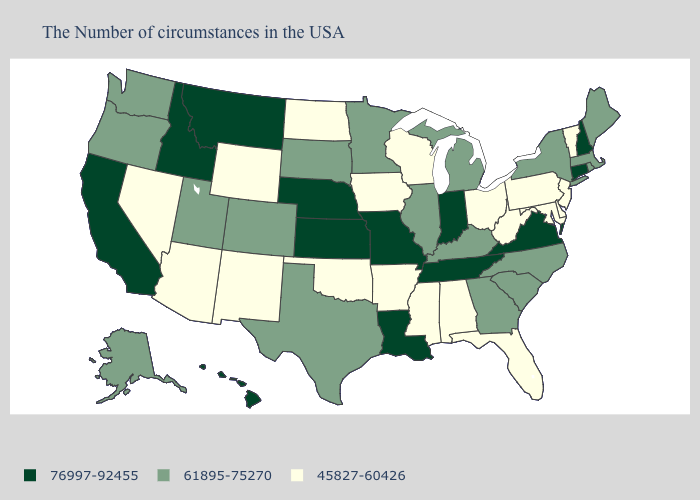What is the lowest value in the USA?
Keep it brief. 45827-60426. Name the states that have a value in the range 76997-92455?
Concise answer only. New Hampshire, Connecticut, Virginia, Indiana, Tennessee, Louisiana, Missouri, Kansas, Nebraska, Montana, Idaho, California, Hawaii. What is the value of Ohio?
Concise answer only. 45827-60426. Among the states that border Kansas , does Missouri have the highest value?
Keep it brief. Yes. What is the value of North Carolina?
Keep it brief. 61895-75270. Does the map have missing data?
Keep it brief. No. Among the states that border Ohio , does Indiana have the highest value?
Concise answer only. Yes. Which states have the lowest value in the South?
Quick response, please. Delaware, Maryland, West Virginia, Florida, Alabama, Mississippi, Arkansas, Oklahoma. What is the value of West Virginia?
Write a very short answer. 45827-60426. Name the states that have a value in the range 76997-92455?
Short answer required. New Hampshire, Connecticut, Virginia, Indiana, Tennessee, Louisiana, Missouri, Kansas, Nebraska, Montana, Idaho, California, Hawaii. Among the states that border Ohio , which have the lowest value?
Give a very brief answer. Pennsylvania, West Virginia. What is the value of Vermont?
Answer briefly. 45827-60426. Does New Mexico have the lowest value in the West?
Write a very short answer. Yes. Does Iowa have a lower value than Idaho?
Answer briefly. Yes. Does Louisiana have the lowest value in the South?
Quick response, please. No. 